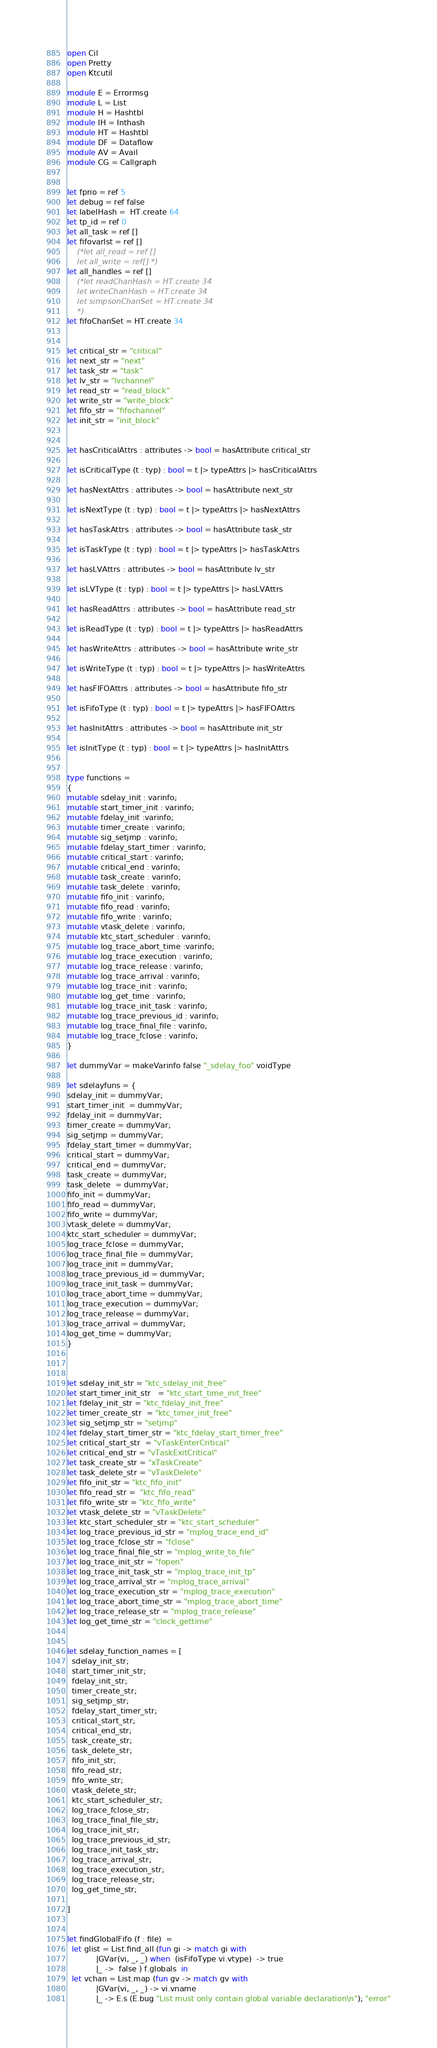Convert code to text. <code><loc_0><loc_0><loc_500><loc_500><_OCaml_>open Cil
open Pretty
open Ktcutil

module E = Errormsg
module L = List
module H = Hashtbl
module IH = Inthash
module HT = Hashtbl
module DF = Dataflow
module AV = Avail
module CG = Callgraph


let fprio = ref 5
let debug = ref false
let labelHash =  HT.create 64
let tp_id = ref 0
let all_task = ref []
let fifovarlst = ref []
	(*let all_read = ref []
	let all_write = ref[] *)
let all_handles = ref []
	(*let readChanHash = HT.create 34
	let writeChanHash = HT.create 34
	let simpsonChanSet = HT.create 34
	*)
let fifoChanSet = HT.create 34


let critical_str = "critical"
let next_str = "next"
let task_str = "task"
let lv_str = "lvchannel"
let read_str = "read_block"
let write_str = "write_block"
let fifo_str = "fifochannel"
let init_str = "init_block"


let hasCriticalAttrs : attributes -> bool = hasAttribute critical_str

let isCriticalType (t : typ) : bool = t |> typeAttrs |> hasCriticalAttrs

let hasNextAttrs : attributes -> bool = hasAttribute next_str

let isNextType (t : typ) : bool = t |> typeAttrs |> hasNextAttrs

let hasTaskAttrs : attributes -> bool = hasAttribute task_str

let isTaskType (t : typ) : bool = t |> typeAttrs |> hasTaskAttrs

let hasLVAttrs : attributes -> bool = hasAttribute lv_str

let isLVType (t : typ) : bool = t |> typeAttrs |> hasLVAttrs

let hasReadAttrs : attributes -> bool = hasAttribute read_str

let isReadType (t : typ) : bool = t |> typeAttrs |> hasReadAttrs

let hasWriteAttrs : attributes -> bool = hasAttribute write_str

let isWriteType (t : typ) : bool = t |> typeAttrs |> hasWriteAttrs

let hasFIFOAttrs : attributes -> bool = hasAttribute fifo_str

let isFifoType (t : typ) : bool = t |> typeAttrs |> hasFIFOAttrs

let hasInitAttrs : attributes -> bool = hasAttribute init_str

let isInitType (t : typ) : bool = t |> typeAttrs |> hasInitAttrs


type functions =
{
mutable sdelay_init : varinfo;
mutable start_timer_init : varinfo;
mutable fdelay_init :varinfo;
mutable timer_create : varinfo;
mutable sig_setjmp : varinfo;
mutable fdelay_start_timer : varinfo;
mutable critical_start : varinfo;
mutable critical_end : varinfo;
mutable task_create : varinfo;
mutable task_delete : varinfo;
mutable fifo_init : varinfo;
mutable fifo_read : varinfo;
mutable fifo_write : varinfo;
mutable vtask_delete : varinfo;
mutable ktc_start_scheduler : varinfo;
mutable log_trace_abort_time :varinfo;
mutable log_trace_execution : varinfo;
mutable log_trace_release : varinfo;
mutable log_trace_arrival : varinfo;
mutable log_trace_init : varinfo;
mutable log_get_time : varinfo;
mutable log_trace_init_task : varinfo;
mutable log_trace_previous_id : varinfo;
mutable log_trace_final_file : varinfo;
mutable log_trace_fclose : varinfo;
}

let dummyVar = makeVarinfo false "_sdelay_foo" voidType

let sdelayfuns = {
sdelay_init = dummyVar;
start_timer_init  = dummyVar;
fdelay_init = dummyVar;
timer_create = dummyVar;
sig_setjmp = dummyVar;
fdelay_start_timer = dummyVar;
critical_start = dummyVar;
critical_end = dummyVar;
task_create = dummyVar;
task_delete  = dummyVar;
fifo_init = dummyVar;
fifo_read = dummyVar;
fifo_write = dummyVar;
vtask_delete = dummyVar;
ktc_start_scheduler = dummyVar;
log_trace_fclose = dummyVar;
log_trace_final_file = dummyVar;
log_trace_init = dummyVar;
log_trace_previous_id = dummyVar;
log_trace_init_task = dummyVar;
log_trace_abort_time = dummyVar;
log_trace_execution = dummyVar;
log_trace_release = dummyVar;
log_trace_arrival = dummyVar;
log_get_time = dummyVar;
}



let sdelay_init_str = "ktc_sdelay_init_free"
let start_timer_init_str   = "ktc_start_time_init_free"
let fdelay_init_str = "ktc_fdelay_init_free"
let timer_create_str  = "ktc_timer_init_free"
let sig_setjmp_str = "setjmp"
let fdelay_start_timer_str = "ktc_fdelay_start_timer_free"
let critical_start_str  = "vTaskEnterCritical"
let critical_end_str = "vTaskExitCritical"
let task_create_str = "xTaskCreate"
let task_delete_str = "vTaskDelete"
let fifo_init_str = "ktc_fifo_init"
let fifo_read_str =  "ktc_fifo_read"
let fifo_write_str = "ktc_fifo_write"
let vtask_delete_str = "vTaskDelete"
let ktc_start_scheduler_str = "ktc_start_scheduler"
let log_trace_previous_id_str = "mplog_trace_end_id"
let log_trace_fclose_str = "fclose"
let log_trace_final_file_str = "mplog_write_to_file"
let log_trace_init_str = "fopen"
let log_trace_init_task_str = "mplog_trace_init_tp"
let log_trace_arrival_str = "mplog_trace_arrival"
let log_trace_execution_str = "mplog_trace_execution"
let log_trace_abort_time_str = "mplog_trace_abort_time"
let log_trace_release_str = "mplog_trace_release"
let log_get_time_str = "clock_gettime"


let sdelay_function_names = [
  sdelay_init_str;
  start_timer_init_str;
  fdelay_init_str;
  timer_create_str;
  sig_setjmp_str;
  fdelay_start_timer_str;
  critical_start_str;
  critical_end_str;
  task_create_str;
  task_delete_str;
  fifo_init_str;
  fifo_read_str;
  fifo_write_str;
  vtask_delete_str;
  ktc_start_scheduler_str;
  log_trace_fclose_str;
  log_trace_final_file_str;
  log_trace_init_str;
  log_trace_previous_id_str;
  log_trace_init_task_str;
  log_trace_arrival_str;
  log_trace_execution_str;
  log_trace_release_str;
  log_get_time_str;

]


let findGlobalFifo (f : file)  =
  let glist = List.find_all (fun gi -> match gi with
			|GVar(vi, _, _) when  (isFifoType vi.vtype)  -> true
			|_ ->  false ) f.globals  in
  let vchan = List.map (fun gv -> match gv with
			|GVar(vi, _, _) -> vi.vname
			|_ -> E.s (E.bug "List must only contain global variable declaration\n"); "error"</code> 